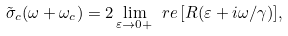<formula> <loc_0><loc_0><loc_500><loc_500>\tilde { \sigma } _ { c } ( \omega + \omega _ { c } ) = 2 \lim _ { \varepsilon \rightarrow 0 + } \ r e \, [ R ( \varepsilon + i \omega / \gamma ) ] ,</formula> 